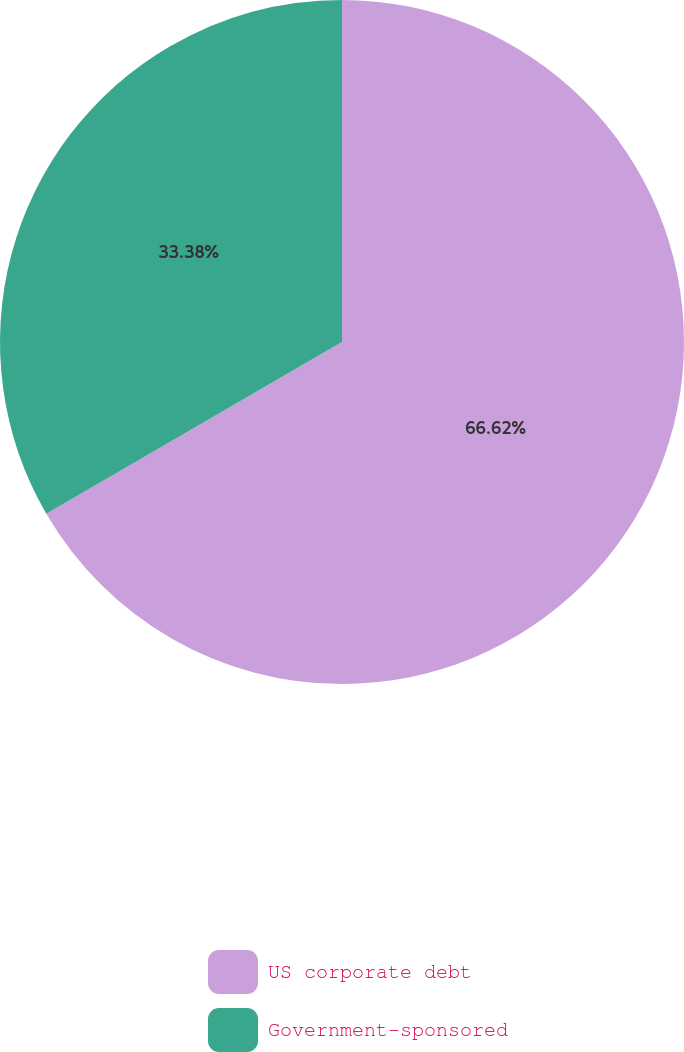Convert chart. <chart><loc_0><loc_0><loc_500><loc_500><pie_chart><fcel>US corporate debt<fcel>Government-sponsored<nl><fcel>66.62%<fcel>33.38%<nl></chart> 